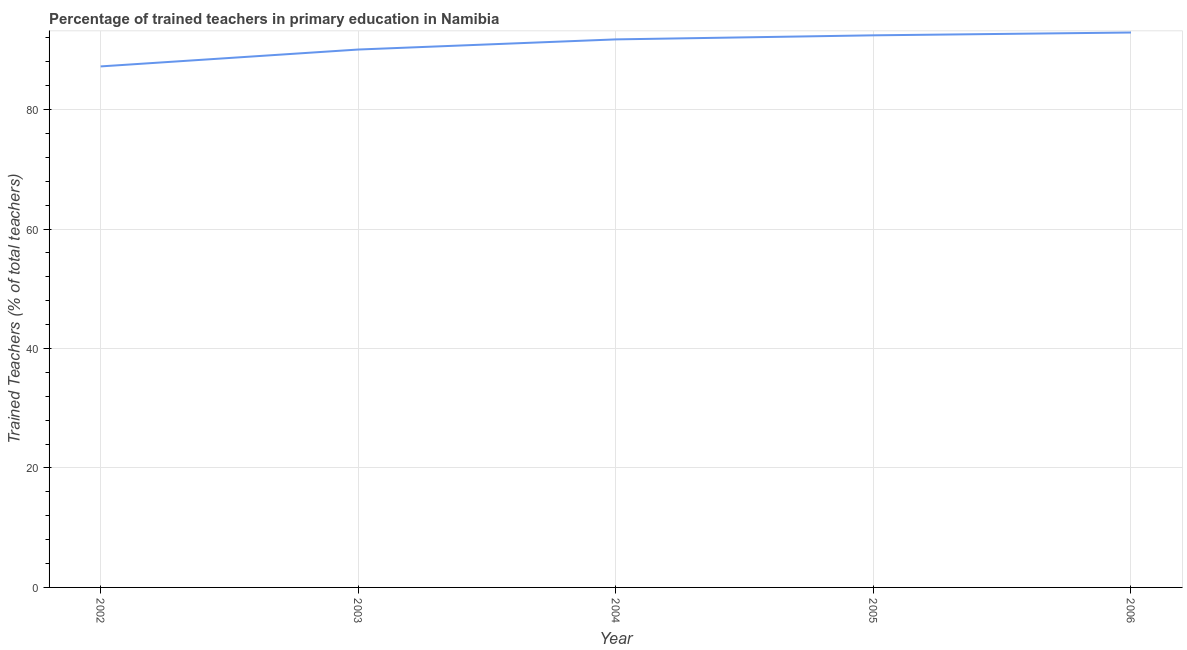What is the percentage of trained teachers in 2002?
Your answer should be very brief. 87.22. Across all years, what is the maximum percentage of trained teachers?
Provide a succinct answer. 92.9. Across all years, what is the minimum percentage of trained teachers?
Provide a succinct answer. 87.22. In which year was the percentage of trained teachers minimum?
Provide a short and direct response. 2002. What is the sum of the percentage of trained teachers?
Offer a terse response. 454.35. What is the difference between the percentage of trained teachers in 2002 and 2005?
Provide a short and direct response. -5.2. What is the average percentage of trained teachers per year?
Your answer should be compact. 90.87. What is the median percentage of trained teachers?
Ensure brevity in your answer.  91.75. In how many years, is the percentage of trained teachers greater than 52 %?
Your answer should be very brief. 5. Do a majority of the years between 2004 and 2003 (inclusive) have percentage of trained teachers greater than 68 %?
Your answer should be very brief. No. What is the ratio of the percentage of trained teachers in 2003 to that in 2004?
Your answer should be very brief. 0.98. Is the difference between the percentage of trained teachers in 2002 and 2005 greater than the difference between any two years?
Your response must be concise. No. What is the difference between the highest and the second highest percentage of trained teachers?
Provide a succinct answer. 0.47. Is the sum of the percentage of trained teachers in 2002 and 2006 greater than the maximum percentage of trained teachers across all years?
Provide a succinct answer. Yes. What is the difference between the highest and the lowest percentage of trained teachers?
Make the answer very short. 5.67. In how many years, is the percentage of trained teachers greater than the average percentage of trained teachers taken over all years?
Offer a very short reply. 3. Does the percentage of trained teachers monotonically increase over the years?
Provide a succinct answer. Yes. How many lines are there?
Your answer should be very brief. 1. How many years are there in the graph?
Give a very brief answer. 5. What is the difference between two consecutive major ticks on the Y-axis?
Your answer should be compact. 20. Are the values on the major ticks of Y-axis written in scientific E-notation?
Ensure brevity in your answer.  No. What is the title of the graph?
Offer a very short reply. Percentage of trained teachers in primary education in Namibia. What is the label or title of the Y-axis?
Offer a very short reply. Trained Teachers (% of total teachers). What is the Trained Teachers (% of total teachers) in 2002?
Ensure brevity in your answer.  87.22. What is the Trained Teachers (% of total teachers) in 2003?
Offer a terse response. 90.05. What is the Trained Teachers (% of total teachers) in 2004?
Your answer should be compact. 91.75. What is the Trained Teachers (% of total teachers) in 2005?
Ensure brevity in your answer.  92.43. What is the Trained Teachers (% of total teachers) in 2006?
Ensure brevity in your answer.  92.9. What is the difference between the Trained Teachers (% of total teachers) in 2002 and 2003?
Provide a short and direct response. -2.83. What is the difference between the Trained Teachers (% of total teachers) in 2002 and 2004?
Your response must be concise. -4.52. What is the difference between the Trained Teachers (% of total teachers) in 2002 and 2005?
Your answer should be compact. -5.2. What is the difference between the Trained Teachers (% of total teachers) in 2002 and 2006?
Ensure brevity in your answer.  -5.67. What is the difference between the Trained Teachers (% of total teachers) in 2003 and 2004?
Ensure brevity in your answer.  -1.7. What is the difference between the Trained Teachers (% of total teachers) in 2003 and 2005?
Your answer should be very brief. -2.38. What is the difference between the Trained Teachers (% of total teachers) in 2003 and 2006?
Provide a succinct answer. -2.85. What is the difference between the Trained Teachers (% of total teachers) in 2004 and 2005?
Provide a succinct answer. -0.68. What is the difference between the Trained Teachers (% of total teachers) in 2004 and 2006?
Offer a terse response. -1.15. What is the difference between the Trained Teachers (% of total teachers) in 2005 and 2006?
Offer a very short reply. -0.47. What is the ratio of the Trained Teachers (% of total teachers) in 2002 to that in 2003?
Provide a succinct answer. 0.97. What is the ratio of the Trained Teachers (% of total teachers) in 2002 to that in 2004?
Offer a very short reply. 0.95. What is the ratio of the Trained Teachers (% of total teachers) in 2002 to that in 2005?
Provide a succinct answer. 0.94. What is the ratio of the Trained Teachers (% of total teachers) in 2002 to that in 2006?
Offer a terse response. 0.94. What is the ratio of the Trained Teachers (% of total teachers) in 2003 to that in 2005?
Offer a very short reply. 0.97. What is the ratio of the Trained Teachers (% of total teachers) in 2004 to that in 2006?
Offer a very short reply. 0.99. What is the ratio of the Trained Teachers (% of total teachers) in 2005 to that in 2006?
Offer a very short reply. 0.99. 